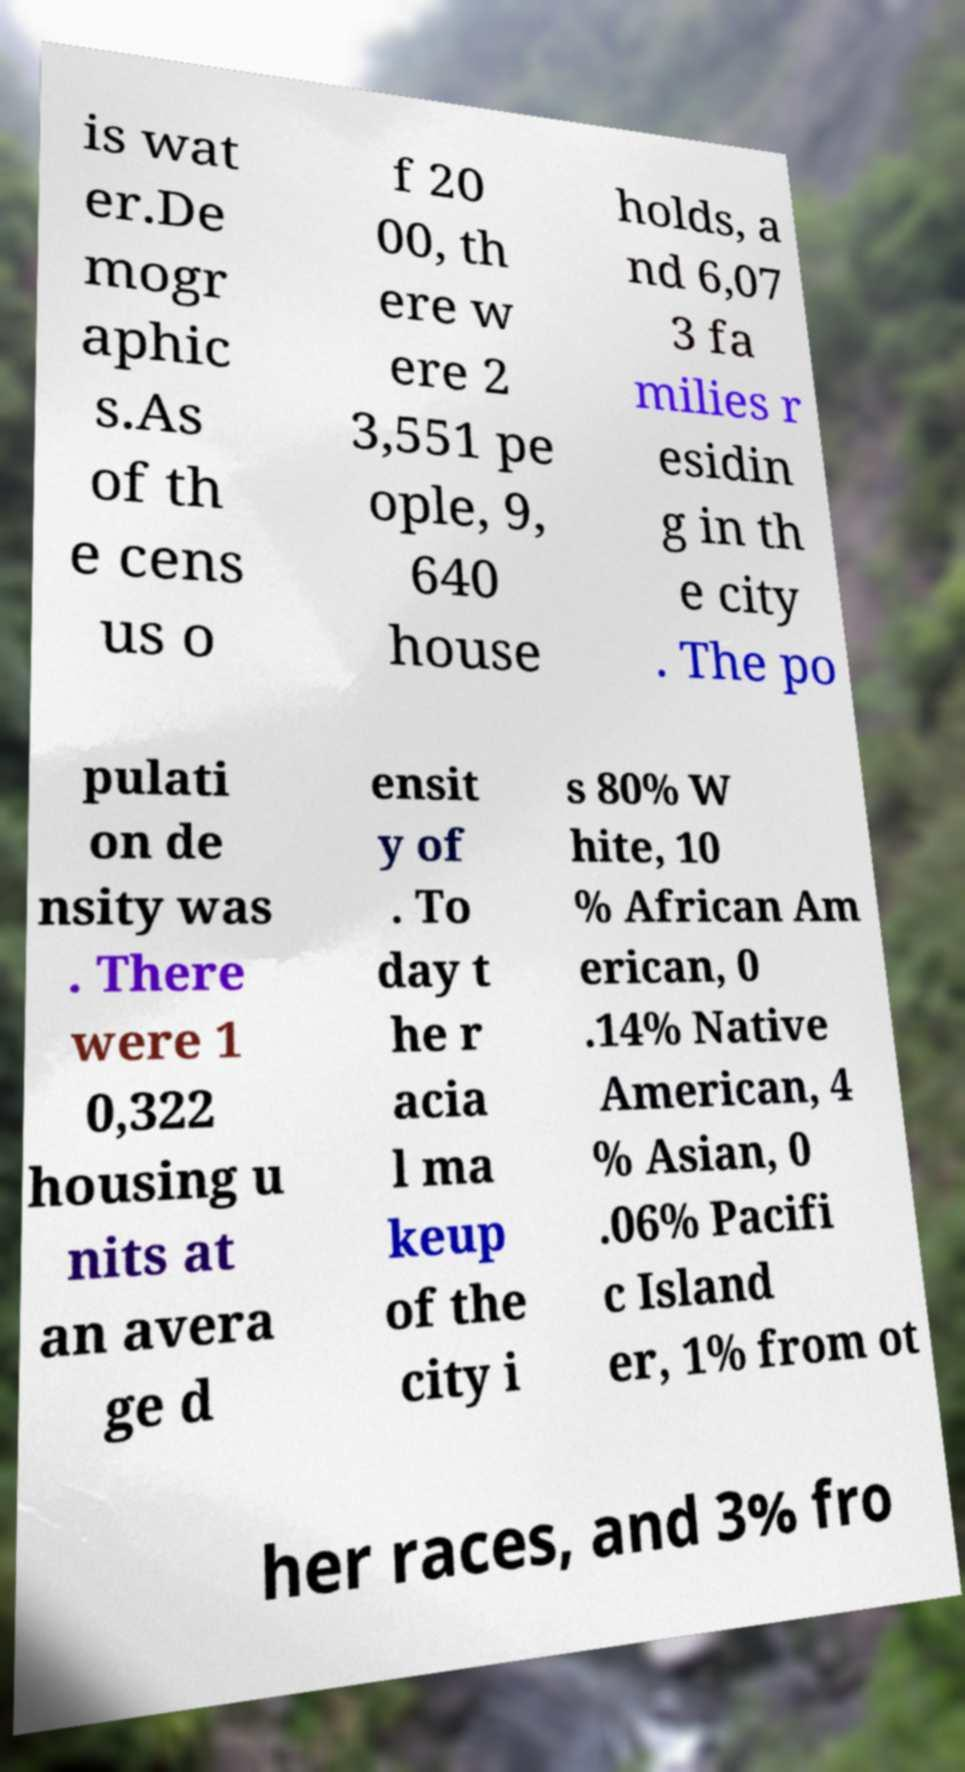For documentation purposes, I need the text within this image transcribed. Could you provide that? is wat er.De mogr aphic s.As of th e cens us o f 20 00, th ere w ere 2 3,551 pe ople, 9, 640 house holds, a nd 6,07 3 fa milies r esidin g in th e city . The po pulati on de nsity was . There were 1 0,322 housing u nits at an avera ge d ensit y of . To day t he r acia l ma keup of the city i s 80% W hite, 10 % African Am erican, 0 .14% Native American, 4 % Asian, 0 .06% Pacifi c Island er, 1% from ot her races, and 3% fro 